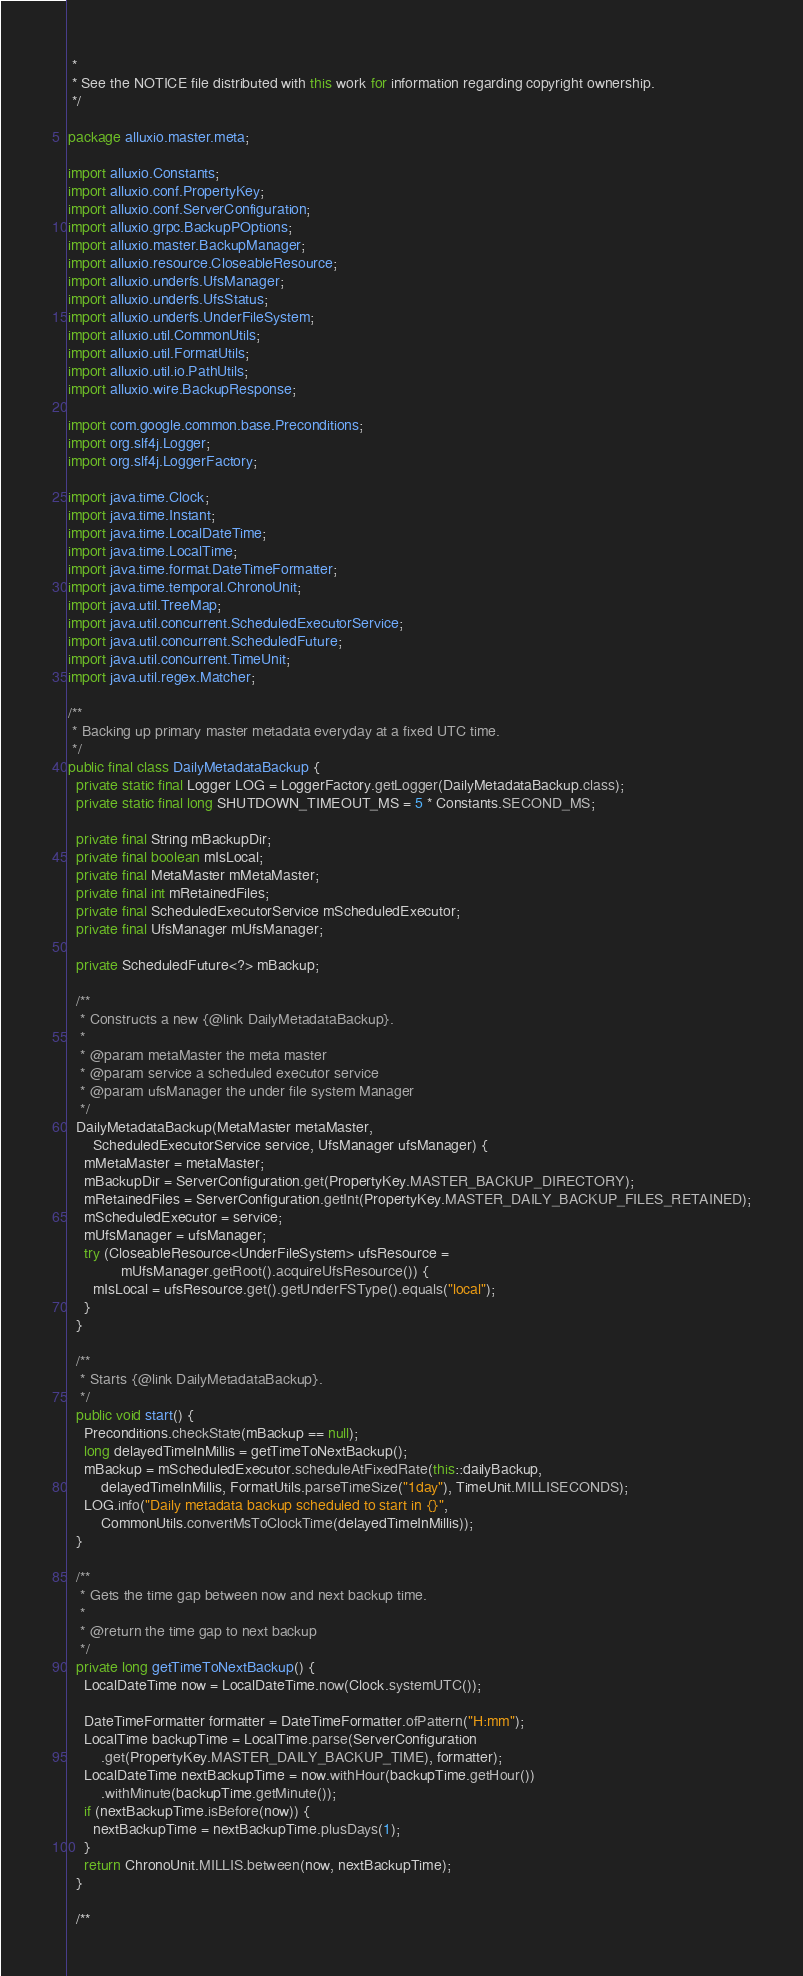<code> <loc_0><loc_0><loc_500><loc_500><_Java_> *
 * See the NOTICE file distributed with this work for information regarding copyright ownership.
 */

package alluxio.master.meta;

import alluxio.Constants;
import alluxio.conf.PropertyKey;
import alluxio.conf.ServerConfiguration;
import alluxio.grpc.BackupPOptions;
import alluxio.master.BackupManager;
import alluxio.resource.CloseableResource;
import alluxio.underfs.UfsManager;
import alluxio.underfs.UfsStatus;
import alluxio.underfs.UnderFileSystem;
import alluxio.util.CommonUtils;
import alluxio.util.FormatUtils;
import alluxio.util.io.PathUtils;
import alluxio.wire.BackupResponse;

import com.google.common.base.Preconditions;
import org.slf4j.Logger;
import org.slf4j.LoggerFactory;

import java.time.Clock;
import java.time.Instant;
import java.time.LocalDateTime;
import java.time.LocalTime;
import java.time.format.DateTimeFormatter;
import java.time.temporal.ChronoUnit;
import java.util.TreeMap;
import java.util.concurrent.ScheduledExecutorService;
import java.util.concurrent.ScheduledFuture;
import java.util.concurrent.TimeUnit;
import java.util.regex.Matcher;

/**
 * Backing up primary master metadata everyday at a fixed UTC time.
 */
public final class DailyMetadataBackup {
  private static final Logger LOG = LoggerFactory.getLogger(DailyMetadataBackup.class);
  private static final long SHUTDOWN_TIMEOUT_MS = 5 * Constants.SECOND_MS;

  private final String mBackupDir;
  private final boolean mIsLocal;
  private final MetaMaster mMetaMaster;
  private final int mRetainedFiles;
  private final ScheduledExecutorService mScheduledExecutor;
  private final UfsManager mUfsManager;

  private ScheduledFuture<?> mBackup;

  /**
   * Constructs a new {@link DailyMetadataBackup}.
   *
   * @param metaMaster the meta master
   * @param service a scheduled executor service
   * @param ufsManager the under file system Manager
   */
  DailyMetadataBackup(MetaMaster metaMaster,
      ScheduledExecutorService service, UfsManager ufsManager) {
    mMetaMaster = metaMaster;
    mBackupDir = ServerConfiguration.get(PropertyKey.MASTER_BACKUP_DIRECTORY);
    mRetainedFiles = ServerConfiguration.getInt(PropertyKey.MASTER_DAILY_BACKUP_FILES_RETAINED);
    mScheduledExecutor = service;
    mUfsManager = ufsManager;
    try (CloseableResource<UnderFileSystem> ufsResource =
             mUfsManager.getRoot().acquireUfsResource()) {
      mIsLocal = ufsResource.get().getUnderFSType().equals("local");
    }
  }

  /**
   * Starts {@link DailyMetadataBackup}.
   */
  public void start() {
    Preconditions.checkState(mBackup == null);
    long delayedTimeInMillis = getTimeToNextBackup();
    mBackup = mScheduledExecutor.scheduleAtFixedRate(this::dailyBackup,
        delayedTimeInMillis, FormatUtils.parseTimeSize("1day"), TimeUnit.MILLISECONDS);
    LOG.info("Daily metadata backup scheduled to start in {}",
        CommonUtils.convertMsToClockTime(delayedTimeInMillis));
  }

  /**
   * Gets the time gap between now and next backup time.
   *
   * @return the time gap to next backup
   */
  private long getTimeToNextBackup() {
    LocalDateTime now = LocalDateTime.now(Clock.systemUTC());

    DateTimeFormatter formatter = DateTimeFormatter.ofPattern("H:mm");
    LocalTime backupTime = LocalTime.parse(ServerConfiguration
        .get(PropertyKey.MASTER_DAILY_BACKUP_TIME), formatter);
    LocalDateTime nextBackupTime = now.withHour(backupTime.getHour())
        .withMinute(backupTime.getMinute());
    if (nextBackupTime.isBefore(now)) {
      nextBackupTime = nextBackupTime.plusDays(1);
    }
    return ChronoUnit.MILLIS.between(now, nextBackupTime);
  }

  /**</code> 